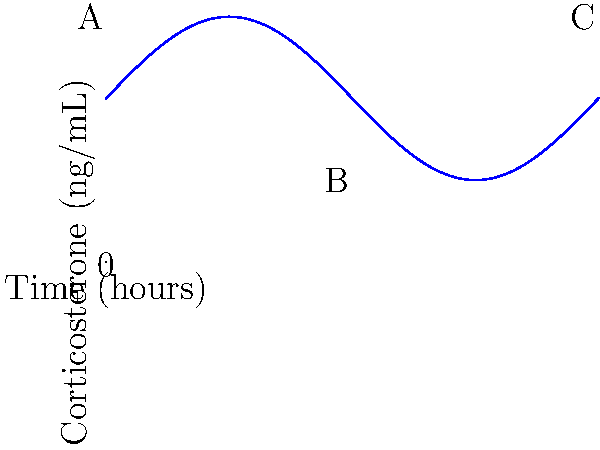Based on the corticosterone fluctuation graph above, at which point (A, B, or C) would you expect the most significant enhancement of long-term potentiation (LTP) in the hippocampus? To answer this question, we need to consider the relationship between corticosterone levels and synaptic plasticity, particularly long-term potentiation (LTP) in the hippocampus:

1. Corticosterone (CORT) is a stress hormone that affects synaptic plasticity in an inverted U-shaped manner.

2. Low levels of CORT (as seen at point B) are generally insufficient to enhance LTP.

3. Very high levels of CORT (as seen at points A and C) can impair LTP due to overactivation of glucocorticoid receptors.

4. Moderate increases in CORT from baseline typically enhance LTP through activation of mineralocorticoid receptors and optimal activation of glucocorticoid receptors.

5. In this graph, point B represents the trough of CORT levels, while points A and C represent peak levels.

6. The rising phase between B and C would likely represent a moderate increase in CORT, which is most conducive to LTP enhancement.

7. Therefore, we would expect the most significant enhancement of LTP to occur slightly after point B, as CORT levels begin to rise moderately.

Given the options provided, point B is closest to this optimal condition for LTP enhancement.
Answer: B 